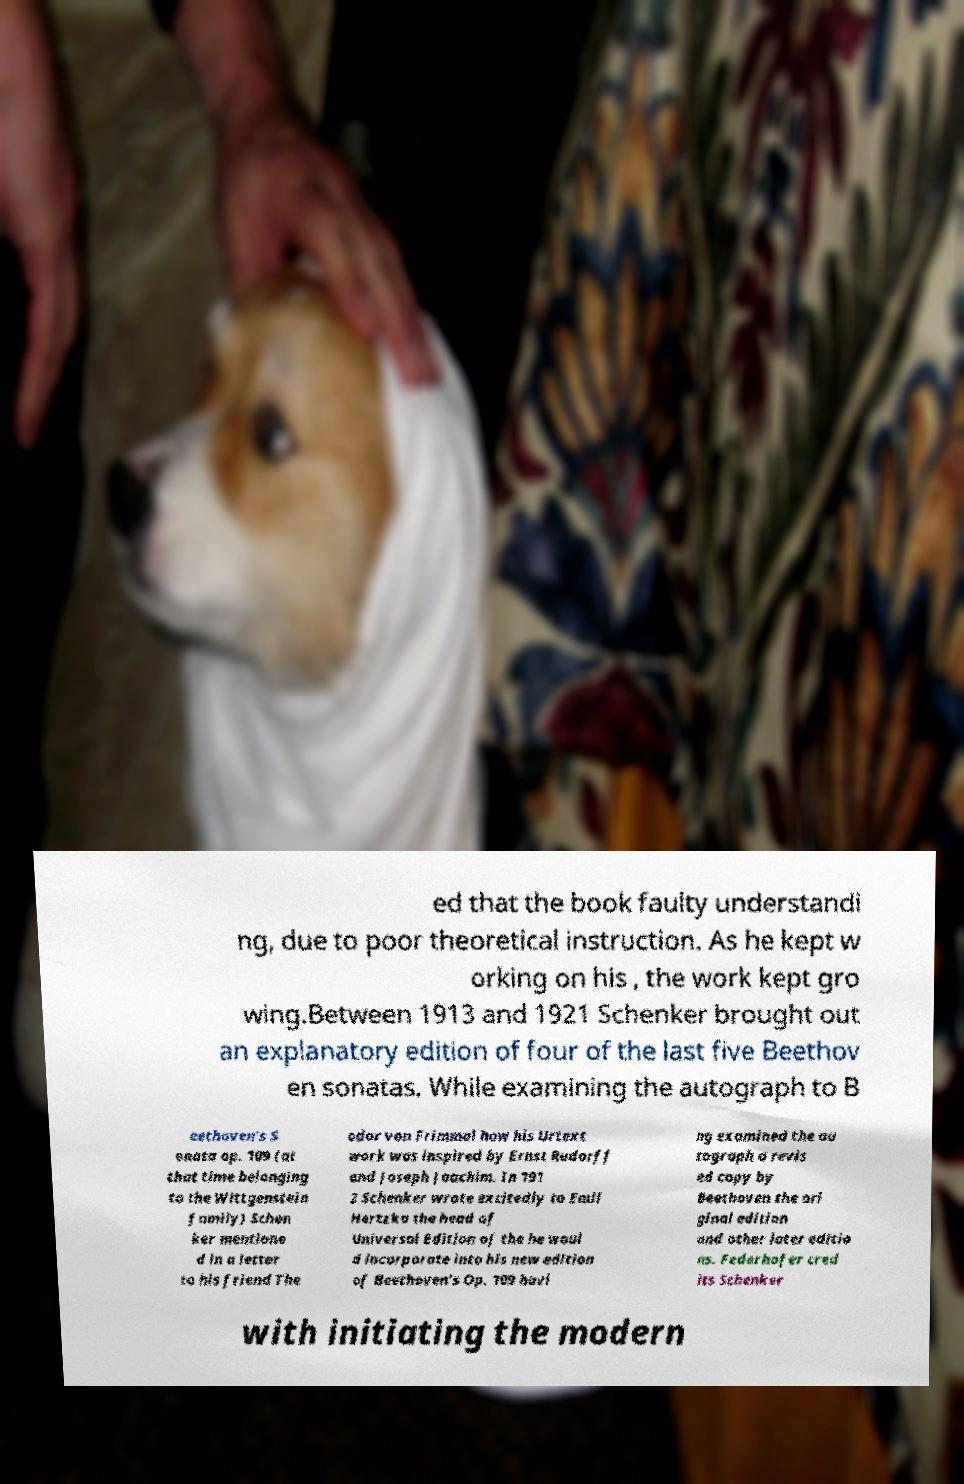Can you read and provide the text displayed in the image?This photo seems to have some interesting text. Can you extract and type it out for me? ed that the book faulty understandi ng, due to poor theoretical instruction. As he kept w orking on his , the work kept gro wing.Between 1913 and 1921 Schenker brought out an explanatory edition of four of the last five Beethov en sonatas. While examining the autograph to B eethoven's S onata op. 109 (at that time belonging to the Wittgenstein family) Schen ker mentione d in a letter to his friend The odor von Frimmel how his Urtext work was inspired by Ernst Rudorff and Joseph Joachim. In 191 2 Schenker wrote excitedly to Emil Hertzka the head of Universal Edition of the he woul d incorporate into his new edition of Beethoven's Op. 109 havi ng examined the au tograph a revis ed copy by Beethoven the ori ginal edition and other later editio ns. Federhofer cred its Schenker with initiating the modern 